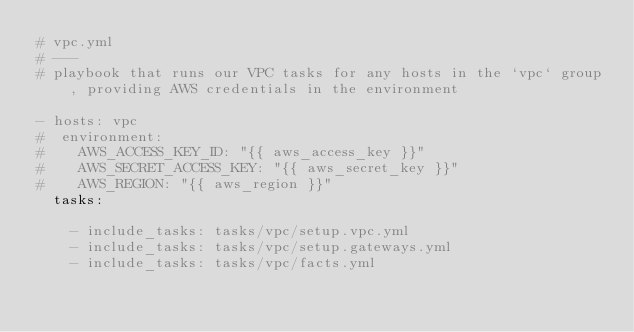<code> <loc_0><loc_0><loc_500><loc_500><_YAML_># vpc.yml
# ---
# playbook that runs our VPC tasks for any hosts in the `vpc` group, providing AWS credentials in the environment 

- hosts: vpc
#  environment:
#    AWS_ACCESS_KEY_ID: "{{ aws_access_key }}"
#    AWS_SECRET_ACCESS_KEY: "{{ aws_secret_key }}"
#    AWS_REGION: "{{ aws_region }}"
  tasks:

    - include_tasks: tasks/vpc/setup.vpc.yml
    - include_tasks: tasks/vpc/setup.gateways.yml
    - include_tasks: tasks/vpc/facts.yml
</code> 